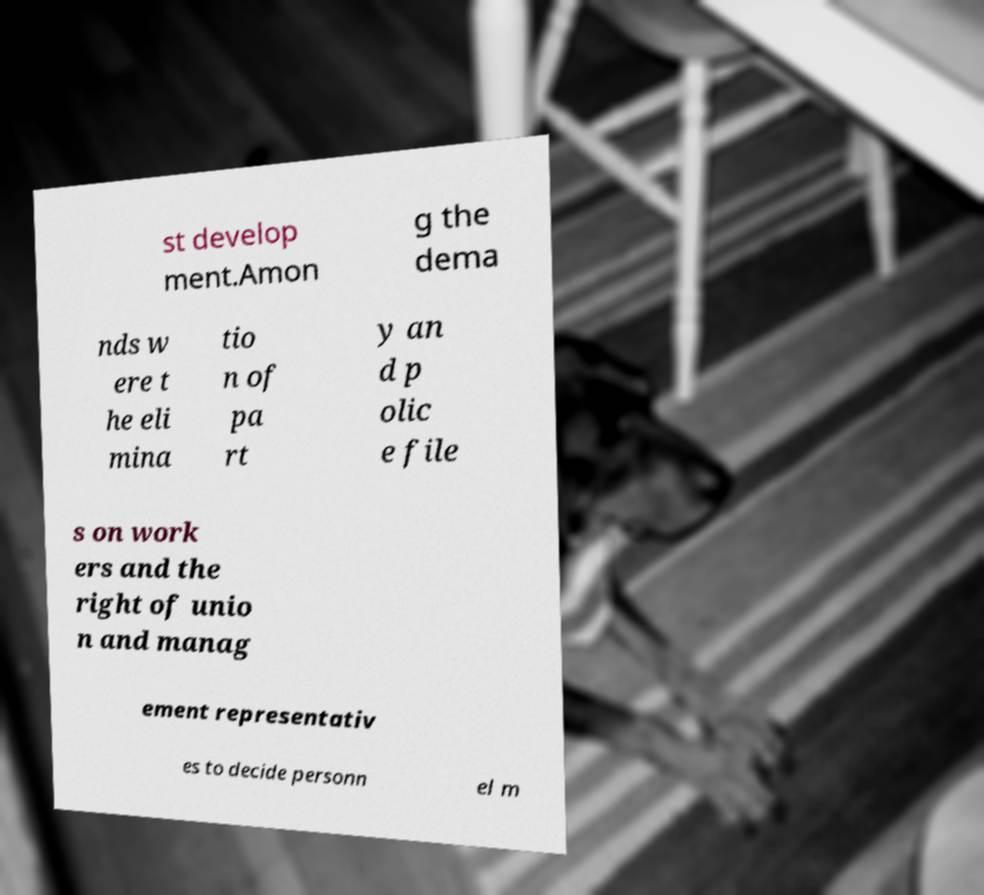Could you assist in decoding the text presented in this image and type it out clearly? st develop ment.Amon g the dema nds w ere t he eli mina tio n of pa rt y an d p olic e file s on work ers and the right of unio n and manag ement representativ es to decide personn el m 